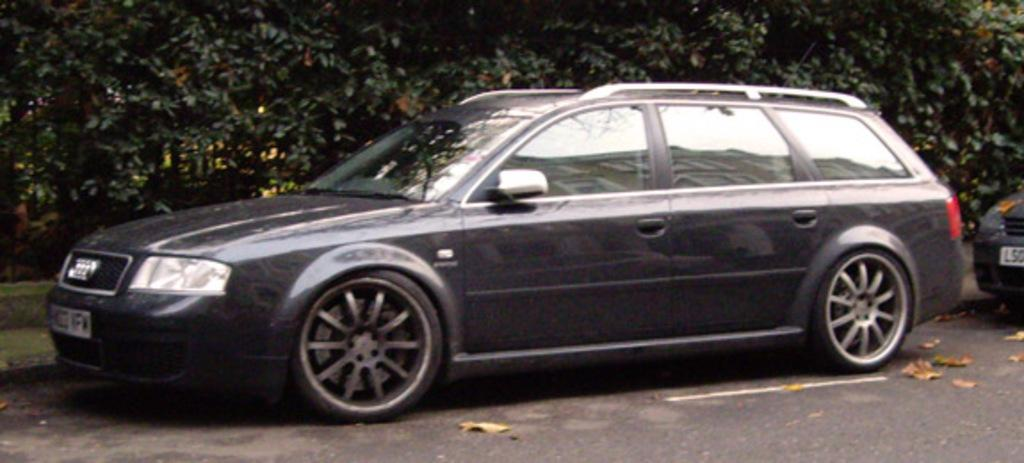What is parked on the road in the image? There is a car parked on the road in the image. What can be seen in the background of the image? There are trees visible in the background of the image. What is on the right side of the image? There is another vehicle with headlights and a number plate on the right side of the image. What type of pen is the bee holding in the image? There is no pen or bee present in the image. 